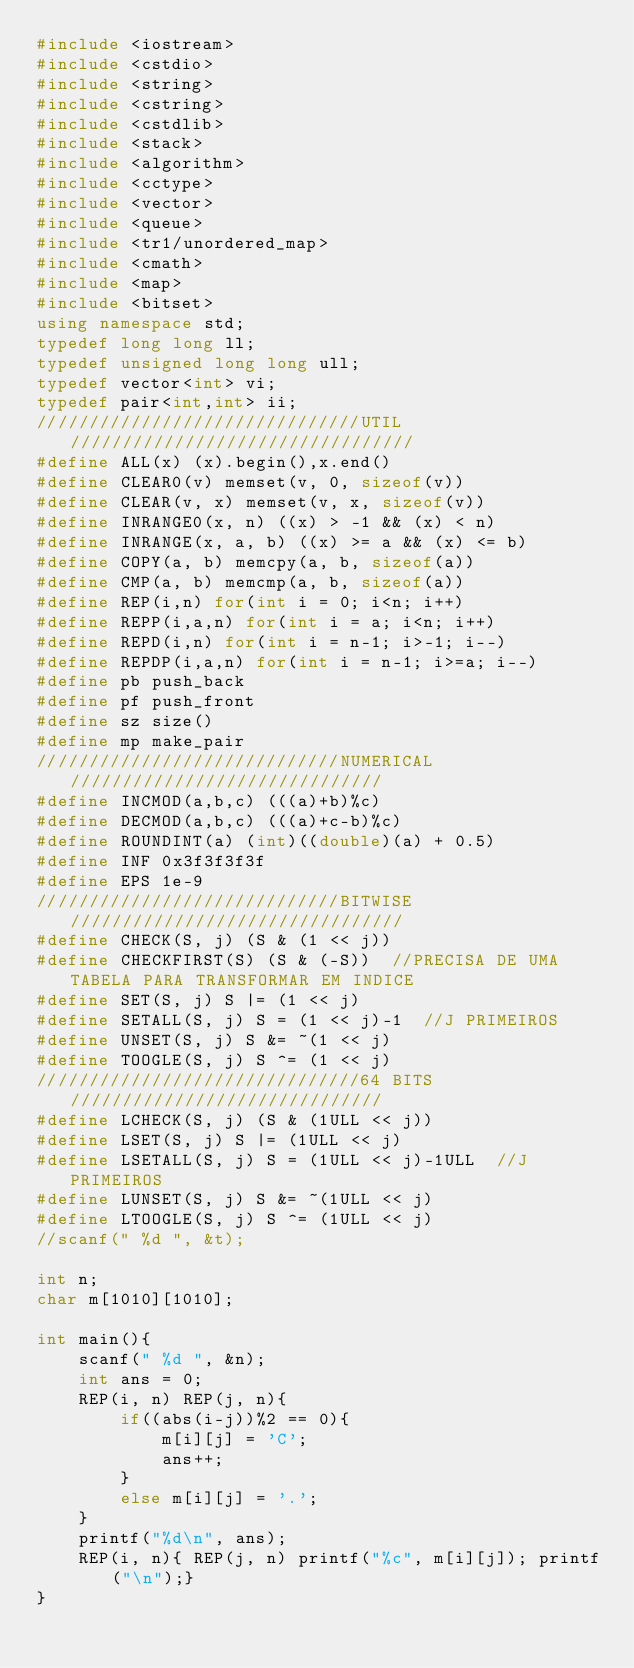<code> <loc_0><loc_0><loc_500><loc_500><_C++_>#include <iostream>
#include <cstdio>
#include <string>
#include <cstring>
#include <cstdlib>
#include <stack>
#include <algorithm>
#include <cctype>
#include <vector>
#include <queue>
#include <tr1/unordered_map>
#include <cmath>
#include <map>
#include <bitset>
using namespace std;
typedef long long ll;
typedef unsigned long long ull;
typedef vector<int> vi;
typedef pair<int,int> ii;
///////////////////////////////UTIL/////////////////////////////////
#define ALL(x) (x).begin(),x.end()
#define CLEAR0(v) memset(v, 0, sizeof(v))
#define CLEAR(v, x) memset(v, x, sizeof(v))
#define INRANGE0(x, n) ((x) > -1 && (x) < n)
#define INRANGE(x, a, b) ((x) >= a && (x) <= b)
#define COPY(a, b) memcpy(a, b, sizeof(a))
#define CMP(a, b) memcmp(a, b, sizeof(a))
#define REP(i,n) for(int i = 0; i<n; i++)
#define REPP(i,a,n) for(int i = a; i<n; i++)
#define REPD(i,n) for(int i = n-1; i>-1; i--)
#define REPDP(i,a,n) for(int i = n-1; i>=a; i--)
#define pb push_back
#define pf push_front
#define sz size()
#define mp make_pair
/////////////////////////////NUMERICAL//////////////////////////////
#define INCMOD(a,b,c) (((a)+b)%c)
#define DECMOD(a,b,c) (((a)+c-b)%c)
#define ROUNDINT(a) (int)((double)(a) + 0.5)
#define INF 0x3f3f3f3f
#define EPS 1e-9
/////////////////////////////BITWISE////////////////////////////////
#define CHECK(S, j) (S & (1 << j))
#define CHECKFIRST(S) (S & (-S))  //PRECISA DE UMA TABELA PARA TRANSFORMAR EM INDICE
#define SET(S, j) S |= (1 << j)
#define SETALL(S, j) S = (1 << j)-1  //J PRIMEIROS
#define UNSET(S, j) S &= ~(1 << j)
#define TOOGLE(S, j) S ^= (1 << j)
///////////////////////////////64 BITS//////////////////////////////
#define LCHECK(S, j) (S & (1ULL << j))
#define LSET(S, j) S |= (1ULL << j)
#define LSETALL(S, j) S = (1ULL << j)-1ULL  //J PRIMEIROS
#define LUNSET(S, j) S &= ~(1ULL << j)
#define LTOOGLE(S, j) S ^= (1ULL << j)
//scanf(" %d ", &t);

int n;
char m[1010][1010];

int main(){
	scanf(" %d ", &n);
	int ans = 0;
	REP(i, n) REP(j, n){
		if((abs(i-j))%2 == 0){
			m[i][j] = 'C';
			ans++;
		}
		else m[i][j] = '.';
	}
	printf("%d\n", ans);
	REP(i, n){ REP(j, n) printf("%c", m[i][j]); printf("\n");}
}
</code> 